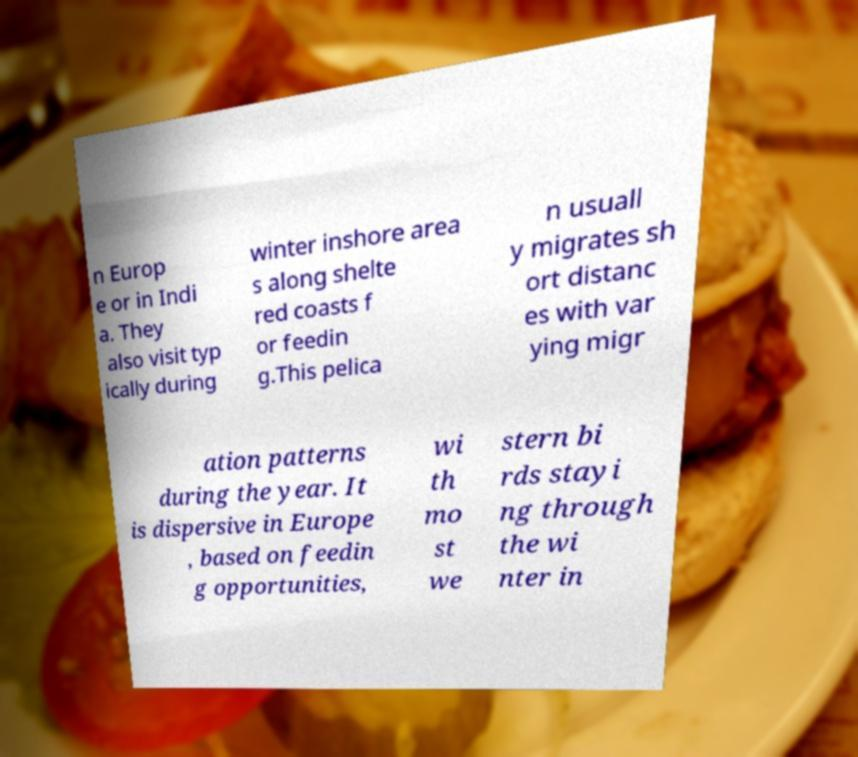What messages or text are displayed in this image? I need them in a readable, typed format. n Europ e or in Indi a. They also visit typ ically during winter inshore area s along shelte red coasts f or feedin g.This pelica n usuall y migrates sh ort distanc es with var ying migr ation patterns during the year. It is dispersive in Europe , based on feedin g opportunities, wi th mo st we stern bi rds stayi ng through the wi nter in 